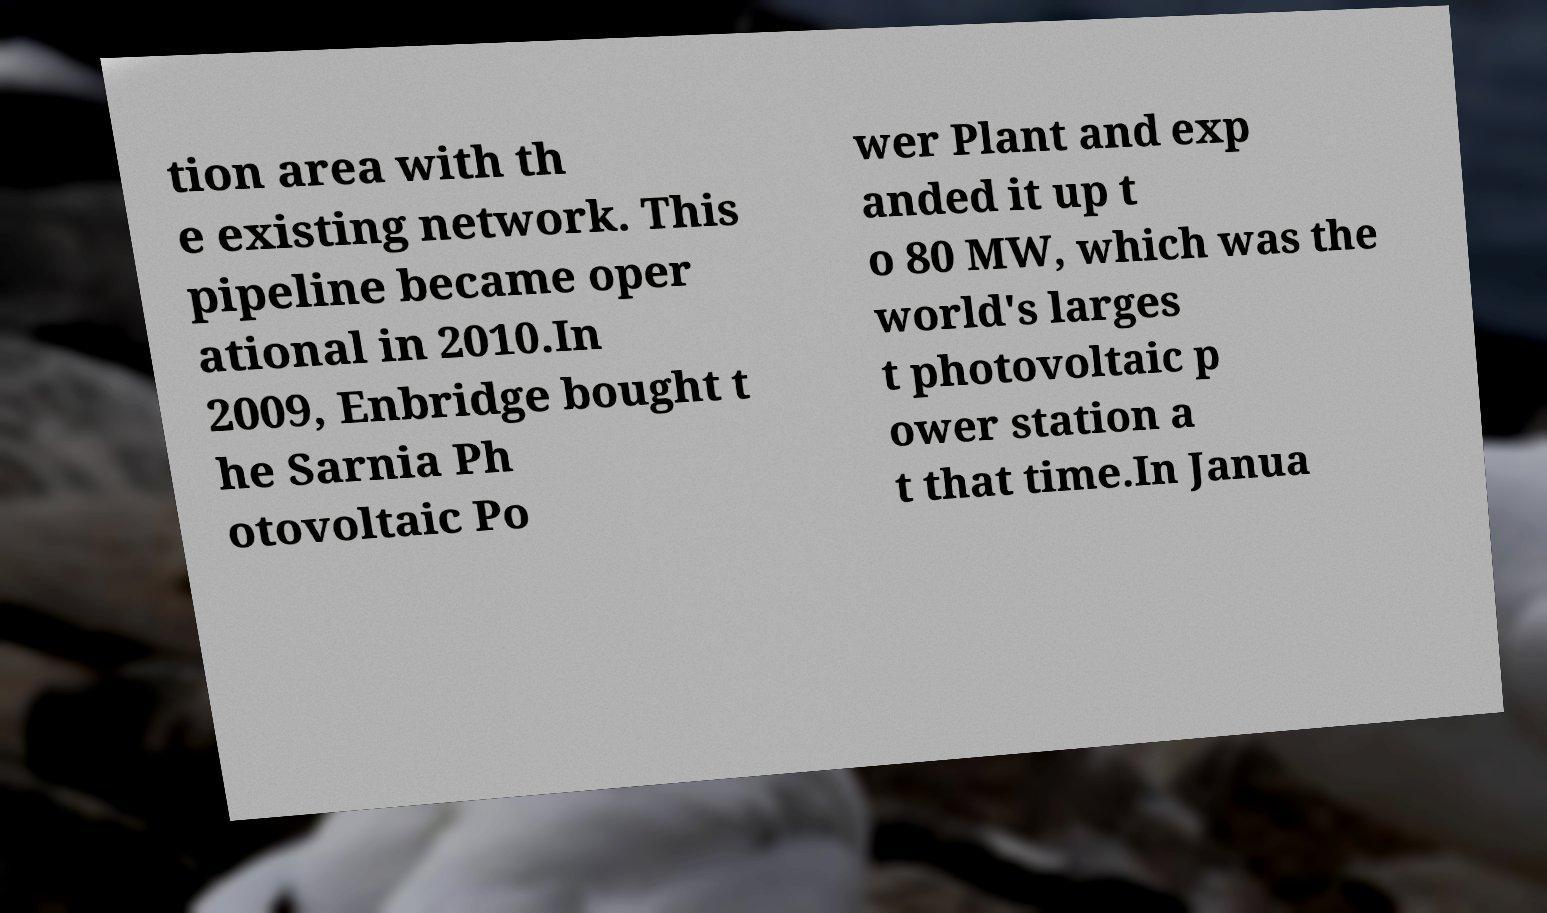Could you assist in decoding the text presented in this image and type it out clearly? tion area with th e existing network. This pipeline became oper ational in 2010.In 2009, Enbridge bought t he Sarnia Ph otovoltaic Po wer Plant and exp anded it up t o 80 MW, which was the world's larges t photovoltaic p ower station a t that time.In Janua 